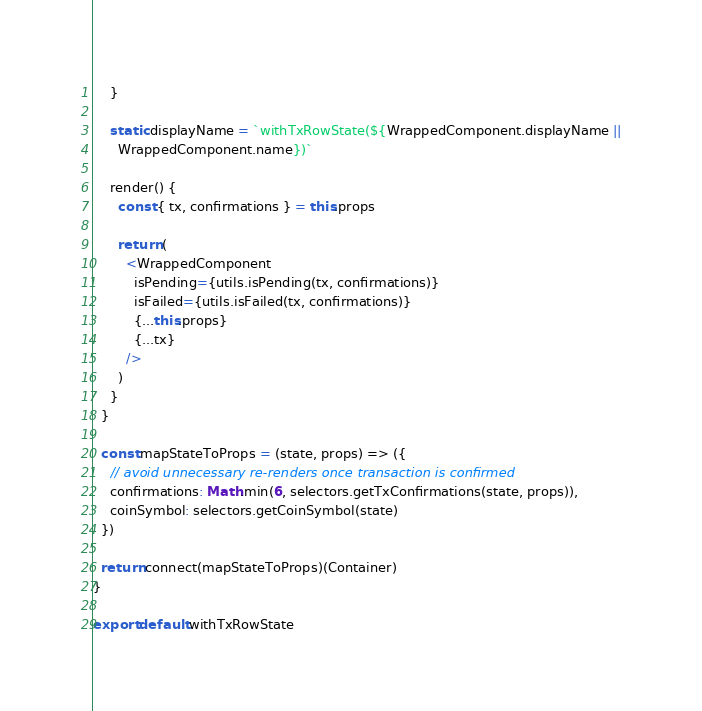<code> <loc_0><loc_0><loc_500><loc_500><_JavaScript_>    }

    static displayName = `withTxRowState(${WrappedComponent.displayName ||
      WrappedComponent.name})`

    render() {
      const { tx, confirmations } = this.props

      return (
        <WrappedComponent
          isPending={utils.isPending(tx, confirmations)}
          isFailed={utils.isFailed(tx, confirmations)}
          {...this.props}
          {...tx}
        />
      )
    }
  }

  const mapStateToProps = (state, props) => ({
    // avoid unnecessary re-renders once transaction is confirmed
    confirmations: Math.min(6, selectors.getTxConfirmations(state, props)),
    coinSymbol: selectors.getCoinSymbol(state)
  })

  return connect(mapStateToProps)(Container)
}

export default withTxRowState
</code> 